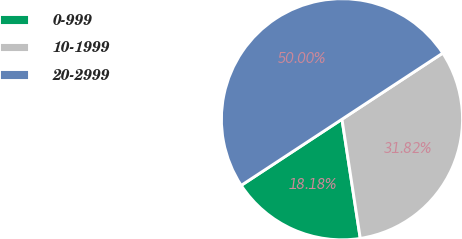<chart> <loc_0><loc_0><loc_500><loc_500><pie_chart><fcel>0-999<fcel>10-1999<fcel>20-2999<nl><fcel>18.18%<fcel>31.82%<fcel>50.0%<nl></chart> 